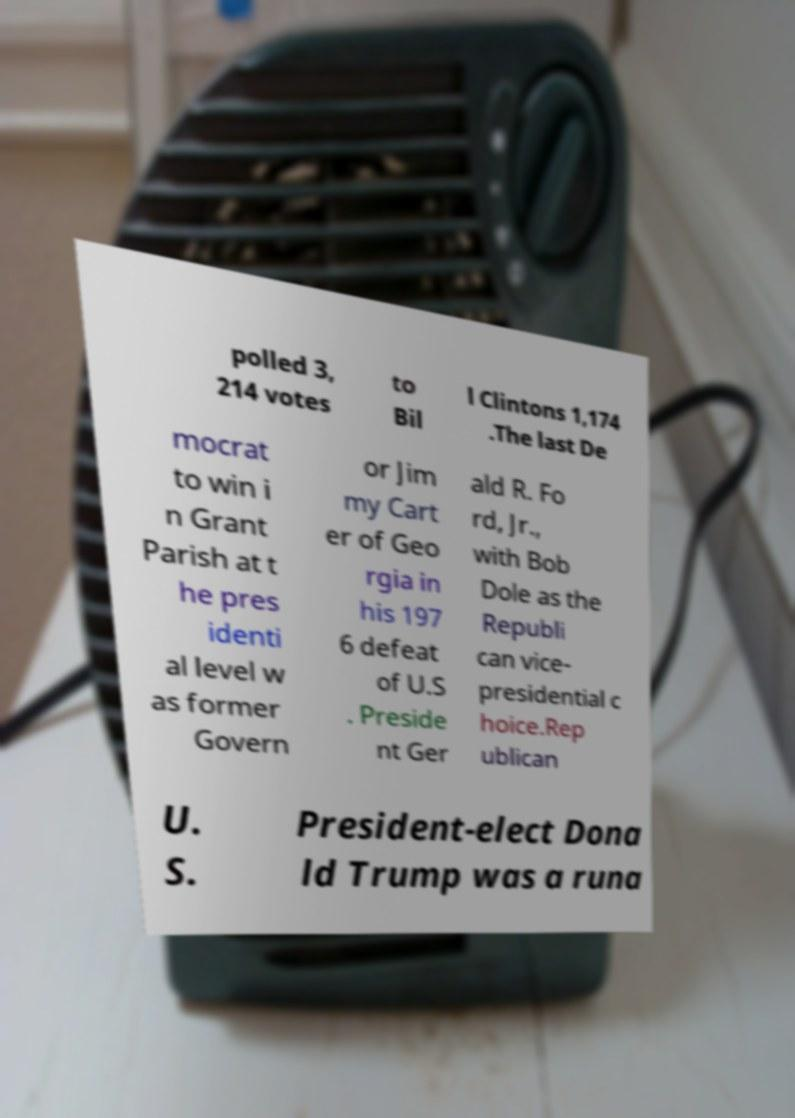I need the written content from this picture converted into text. Can you do that? polled 3, 214 votes to Bil l Clintons 1,174 .The last De mocrat to win i n Grant Parish at t he pres identi al level w as former Govern or Jim my Cart er of Geo rgia in his 197 6 defeat of U.S . Preside nt Ger ald R. Fo rd, Jr., with Bob Dole as the Republi can vice- presidential c hoice.Rep ublican U. S. President-elect Dona ld Trump was a runa 